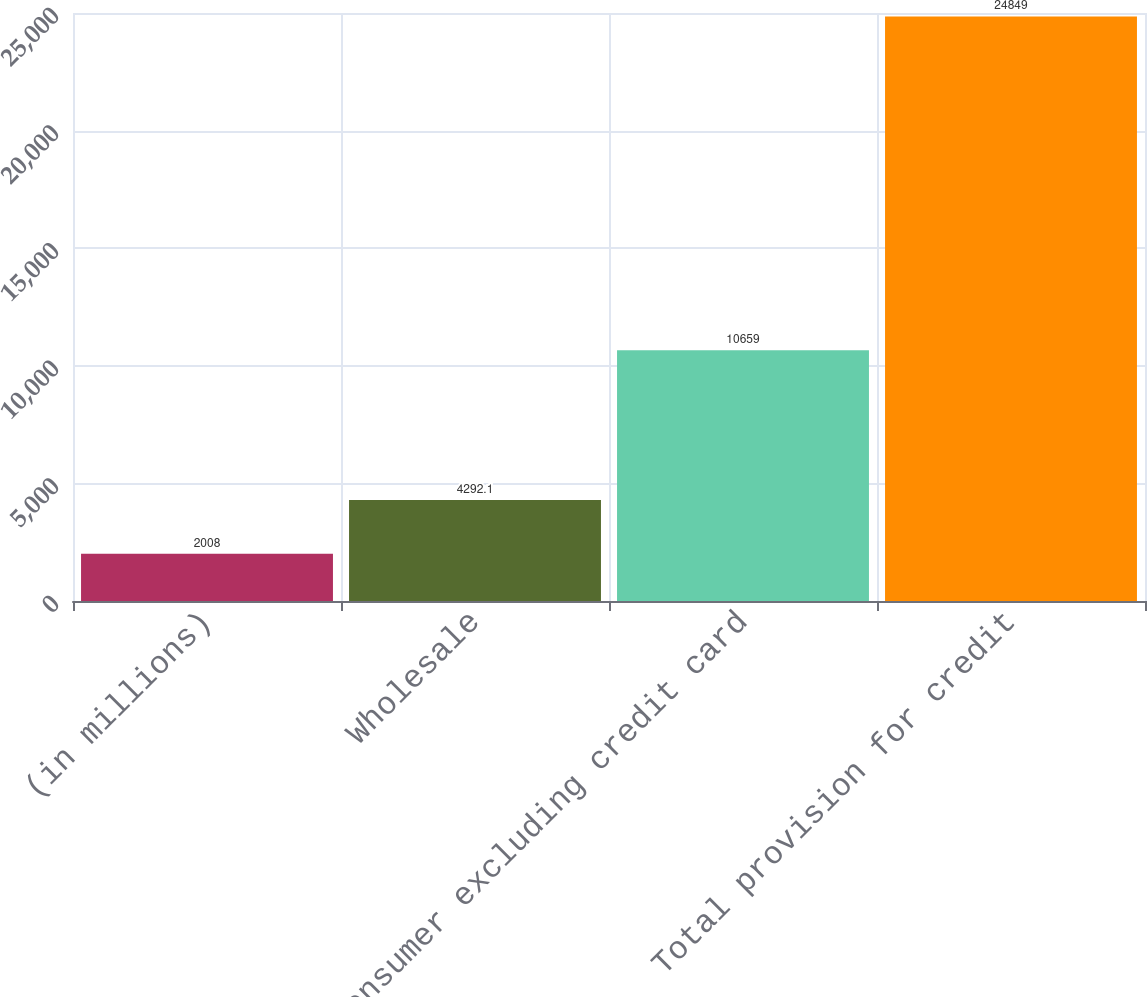Convert chart. <chart><loc_0><loc_0><loc_500><loc_500><bar_chart><fcel>(in millions)<fcel>Wholesale<fcel>Consumer excluding credit card<fcel>Total provision for credit<nl><fcel>2008<fcel>4292.1<fcel>10659<fcel>24849<nl></chart> 